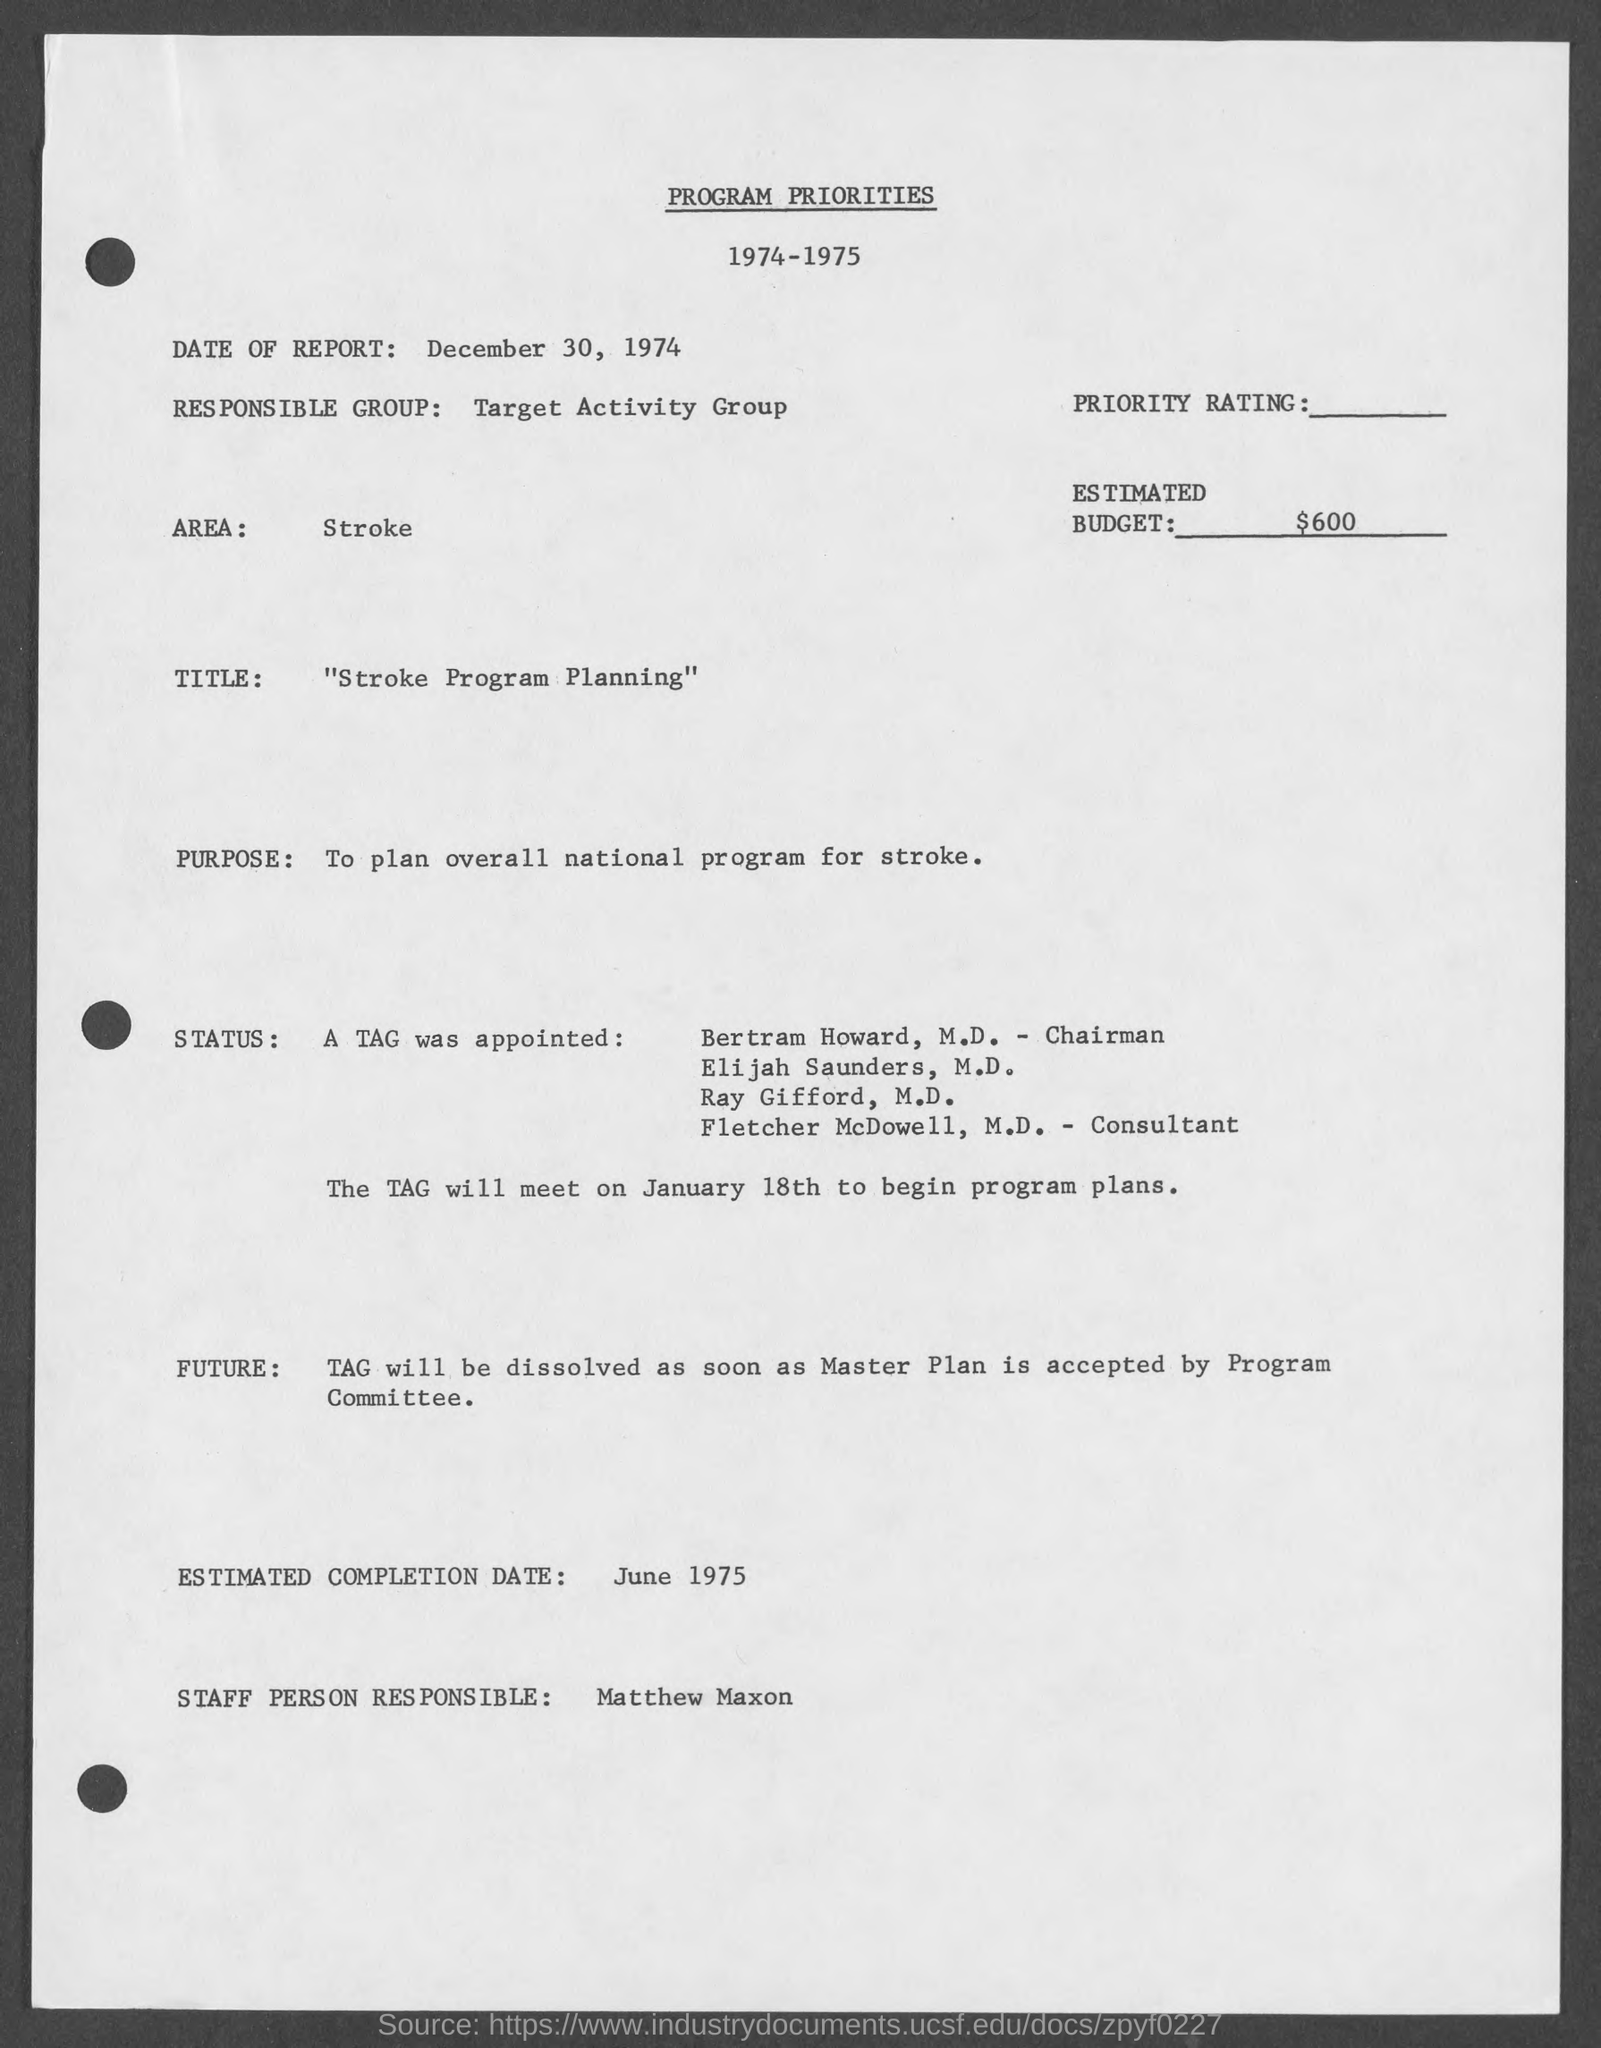List a handful of essential elements in this visual. The date of the report is December 30, 1974. The title of this document is "Stroke Program Planning." Matthew Maxon is the staff person responsible. The purpose of planning an overall national program for stroke is to determine the goals and objectives for preventing, diagnosing, and treating stroke, and to establish strategies and resources for achieving those goals. The estimated completion date is June 1975. 